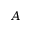<formula> <loc_0><loc_0><loc_500><loc_500>A</formula> 